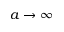Convert formula to latex. <formula><loc_0><loc_0><loc_500><loc_500>a \rightarrow \infty</formula> 